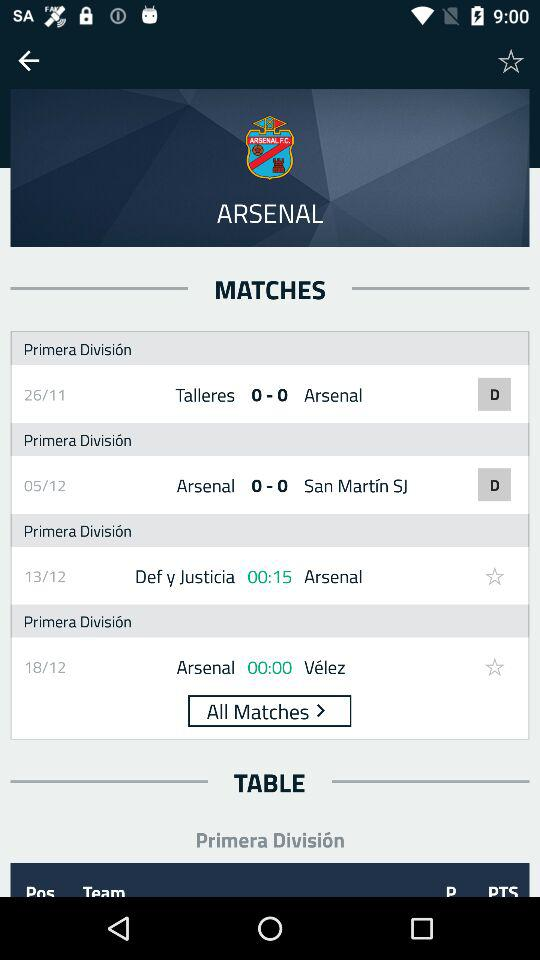When is the match between "Arsenal" and "Vélez" scheduled? The match between "Arsenal" and "Vélez" is scheduled for December 18. 